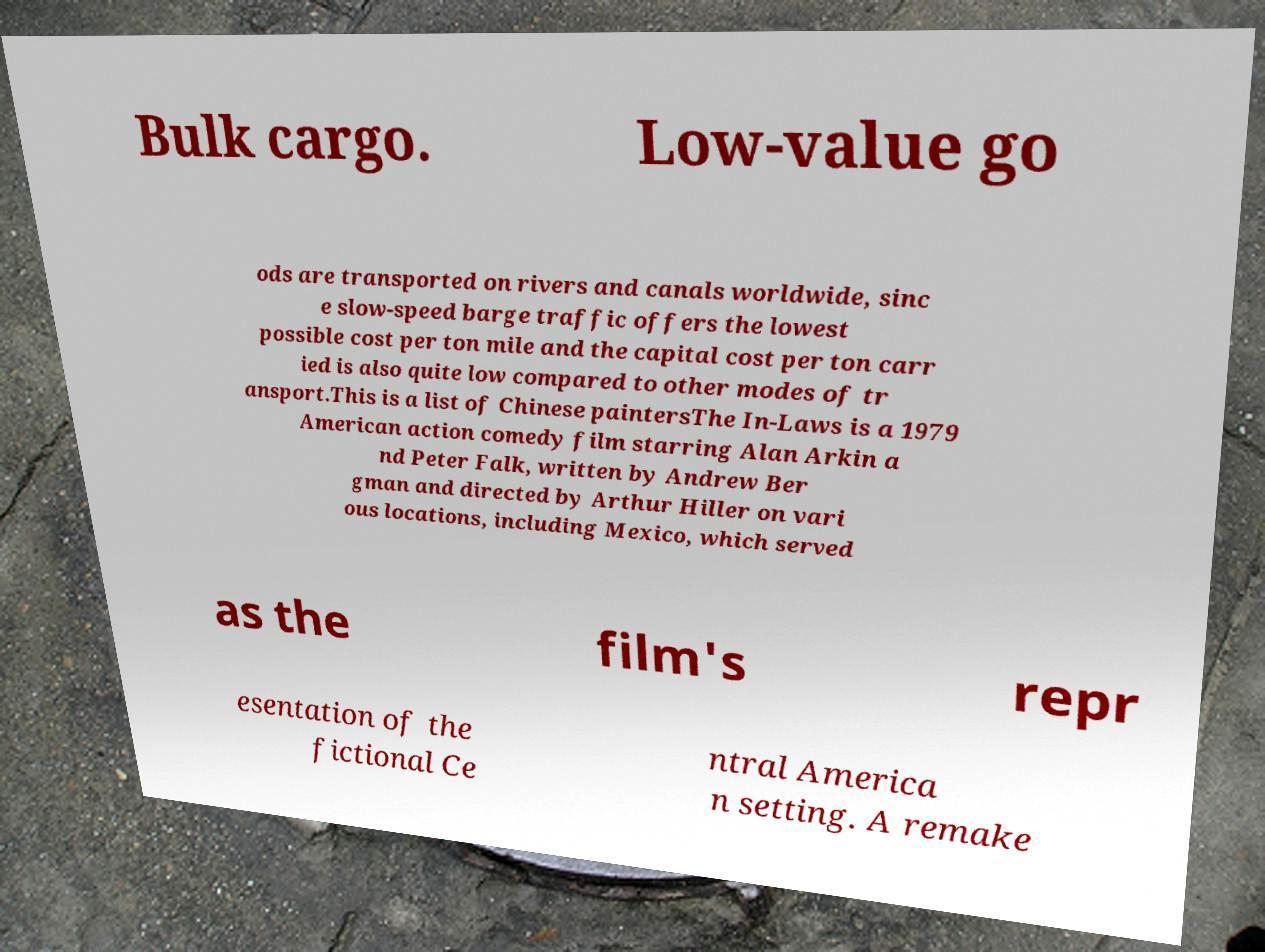There's text embedded in this image that I need extracted. Can you transcribe it verbatim? Bulk cargo. Low-value go ods are transported on rivers and canals worldwide, sinc e slow-speed barge traffic offers the lowest possible cost per ton mile and the capital cost per ton carr ied is also quite low compared to other modes of tr ansport.This is a list of Chinese paintersThe In-Laws is a 1979 American action comedy film starring Alan Arkin a nd Peter Falk, written by Andrew Ber gman and directed by Arthur Hiller on vari ous locations, including Mexico, which served as the film's repr esentation of the fictional Ce ntral America n setting. A remake 